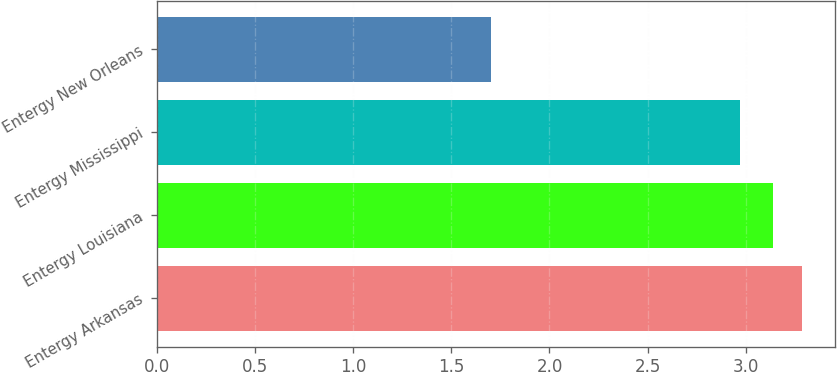Convert chart. <chart><loc_0><loc_0><loc_500><loc_500><bar_chart><fcel>Entergy Arkansas<fcel>Entergy Louisiana<fcel>Entergy Mississippi<fcel>Entergy New Orleans<nl><fcel>3.29<fcel>3.14<fcel>2.97<fcel>1.7<nl></chart> 